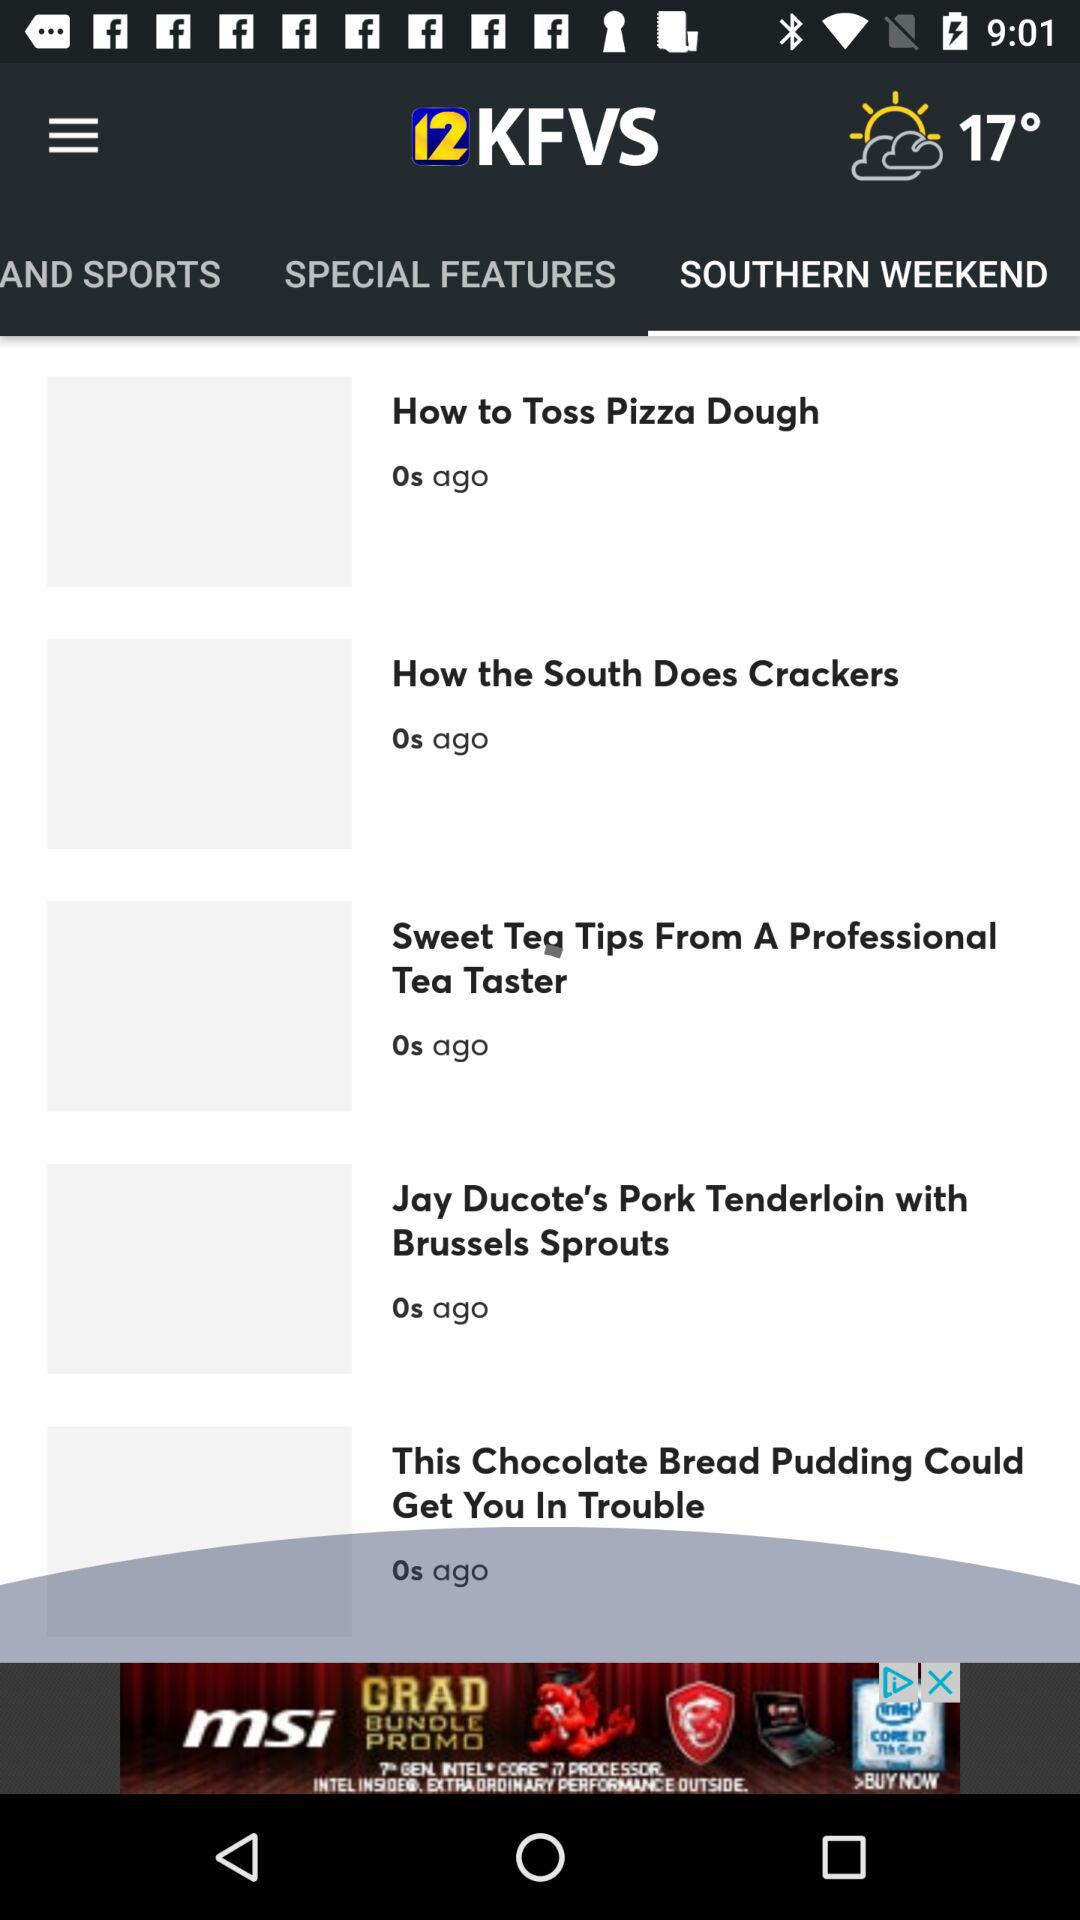How many seconds ago was "How to Toss Pizza Dough" updated? It was last updated 0 seconds ago. 